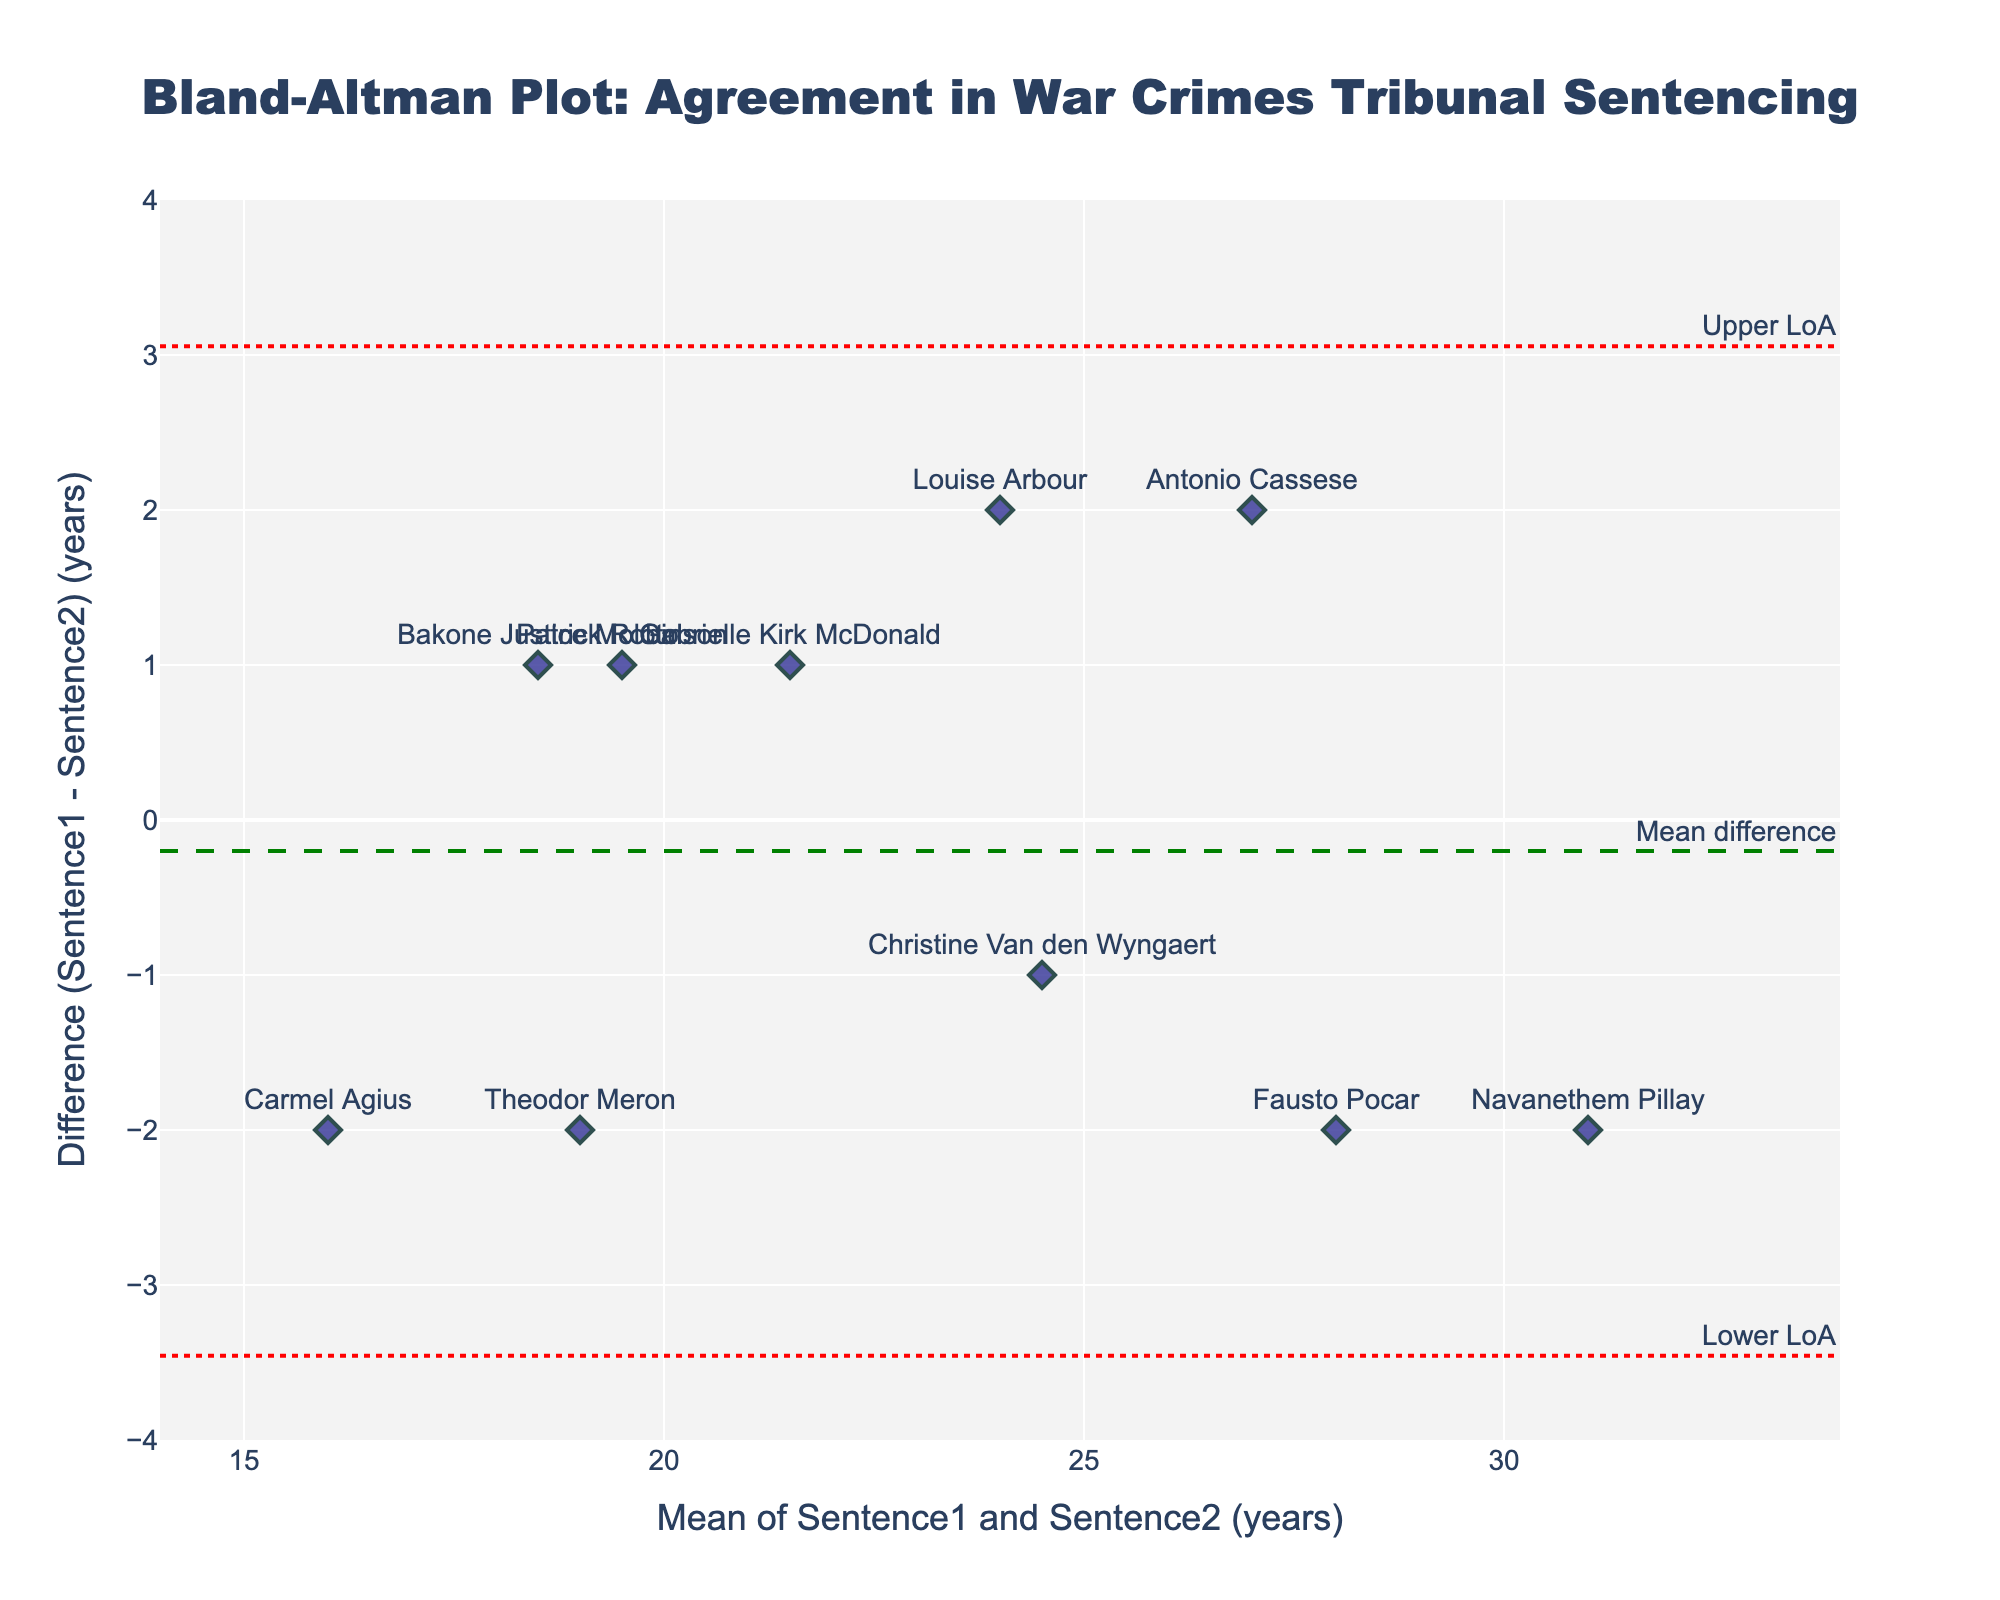How many data points are represented in the plot? Count the number of different judges' names or markers corresponding to the sentences. Each judge provides one data point. There are ten judges listed.
Answer: 10 What is the title of the plot? The title is typically found at the top center of the plot. It helps to understand the subject of the figure. In this case, the title reads "Bland-Altman Plot: Agreement in War Crimes Tribunal Sentencing".
Answer: Bland-Altman Plot: Agreement in War Crimes Tribunal Sentencing What is the mean difference, as indicated by the horizontal line? A dashed green line represents the mean difference. This line is annotated with the text "Mean difference". By observing its position on the y-axis, we can identify the mean difference.
Answer: 0 Where do the upper and lower limits of agreement (LoA) lie? The plot includes two dotted red lines representing the upper and lower limits of agreement. These lines are annotated with texts "Upper LoA" and "Lower LoA". By observing their positions on the y-axis, we can identify the upper and lower LoA values.
Answer: Upper: 3.2, Lower: -3.2 Which judge’s sentences have the largest deviation from each other? The judge with the largest deviation will have the data point furthest from the mean difference line. By observing the vertical distances of individual data points from the mean difference line, we can identify the largest deviation. The largest deviation appears to be for Carmel Agius.
Answer: Carmel Agius What is the mean value of sentencing years for Louise Arbour? The x-axis of the plot represents the mean of Sentence1 and Sentence2 for each judge. The data point labeled "Louise Arbour" will indicate this mean value.
Answer: 24 How many judges have differences in their sentences that fall within the limits of agreement? Data points falling between the upper and lower limits of agreement lines indicate the sentences that conform within the limits. Counting these points will give the answer. All judges except Carmel Agius fall within the limits.
Answer: 9 Which judges have sentence differences below -2? The y-axis represents the difference of Sentence1 - Sentence2. Points below -2 on the y-axis must be examined to identify the corresponding judges. By locating these points, we find Antonio Cassese and Carmel Agius below -2.
Answer: Antonio Cassese, Carmel Agius What is the range of the mean of sentences on the x-axis? The range of the x-axis can be read from the x-tick marks which indicate the min and max limits of the mean sentence value. These are set from 14 to 34.
Answer: 14 to 34 